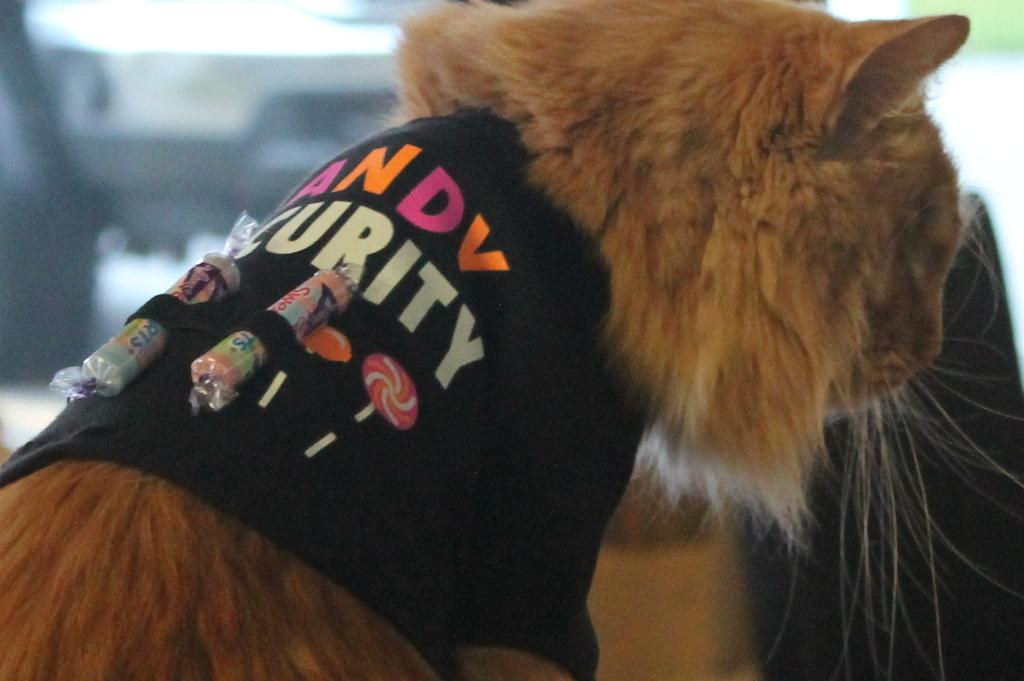What type of animal can be seen in the image? There is a cat present in the image. What color is the cat? The cat is brown in color. Is there anything around the cat's neck? Yes, there is a black cloth or belt around the cat's neck. How would you describe the background of the image? The background of the image is blurred. How many bars of soap can be seen in the image? There are no bars of soap present in the image. What type of vegetation is visible in the image? The provided facts do not mention any vegetation, such as bushes, in the image. 